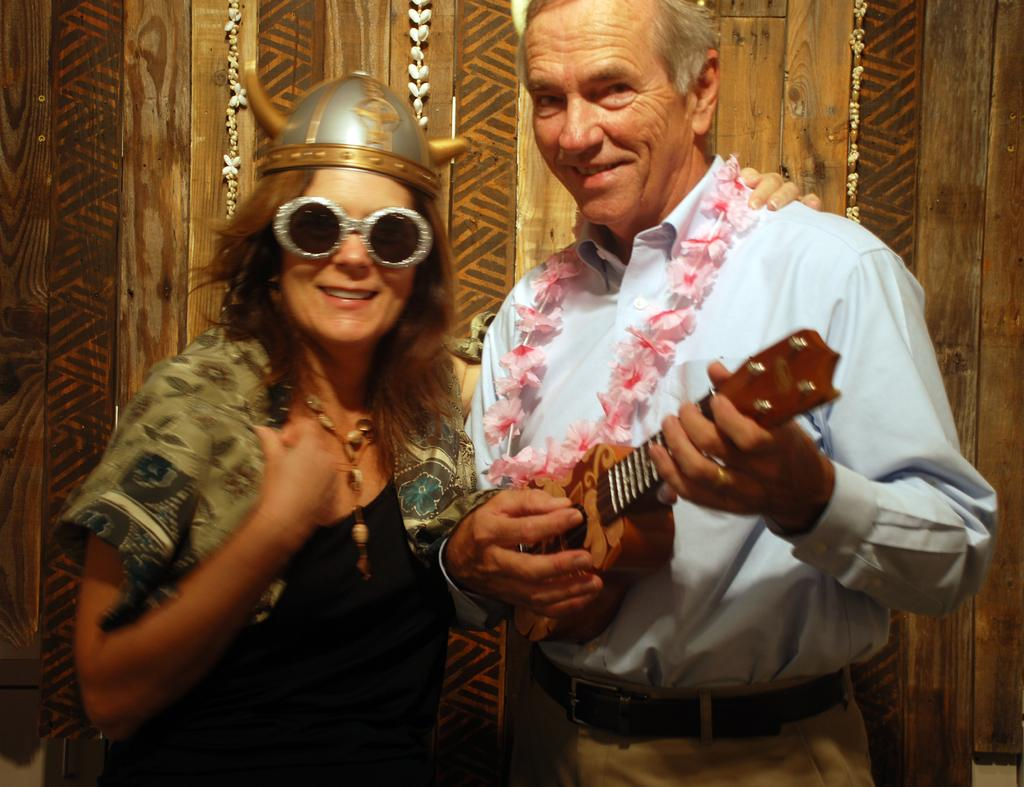Who are the people in the image? There is a woman and a man in the image. What are the people in the image doing? Both the woman and the man are laughing. What object is the man holding in the image? The man is holding a guitar. What type of doll is sitting on the dock in the image? There is no doll or dock present in the image. What type of harmony is being played on the guitar in the image? The image does not depict any music being played, so it is not possible to determine the type of harmony being played on the guitar. 